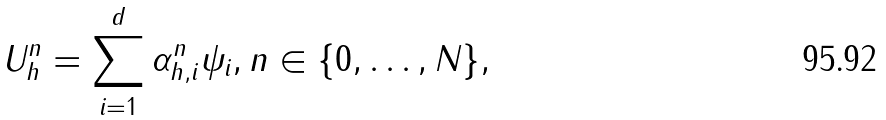Convert formula to latex. <formula><loc_0><loc_0><loc_500><loc_500>U ^ { n } _ { h } = \sum _ { i = 1 } ^ { d } \alpha _ { h , i } ^ { n } \psi _ { i } , n \in \{ 0 , \dots , N \} ,</formula> 